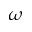Convert formula to latex. <formula><loc_0><loc_0><loc_500><loc_500>\omega</formula> 